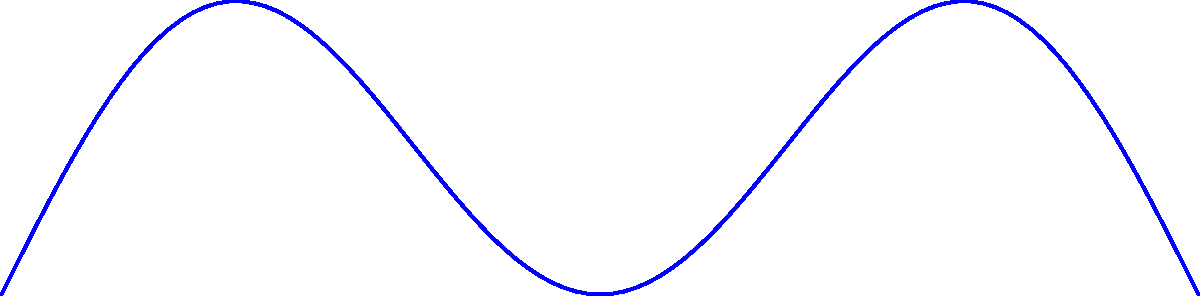You're reliving your glory days on Clemson's Bowman Field, attempting to throw a football for maximum distance. Assuming the football's trajectory follows the function $h(θ) = \sin(2θ)\cos(θ)$, where $h$ is the height and $θ$ is the angle of release in radians, what is the optimal angle to throw the football for maximum distance? To find the optimal angle for maximum distance, we need to follow these steps:

1) The distance traveled by the football is proportional to $\sin(2θ)$. Therefore, we need to maximize this function.

2) To find the maximum of $\sin(2θ)$, we can differentiate it and set it to zero:

   $$\frac{d}{dθ}\sin(2θ) = 2\cos(2θ) = 0$$

3) Solving this equation:
   $\cos(2θ) = 0$
   $2θ = \frac{\pi}{2}$ (since we're in the first quadrant)
   $θ = \frac{\pi}{4}$

4) To confirm this is a maximum, we can check the second derivative:

   $$\frac{d^2}{dθ^2}\sin(2θ) = -4\sin(2θ)$$

   At $θ = \frac{\pi}{4}$, this is negative, confirming a maximum.

5) Convert radians to degrees:

   $$\frac{\pi}{4} \text{ radians} = 45°$$

Therefore, the optimal angle to throw the football for maximum distance is 45°.
Answer: 45° 